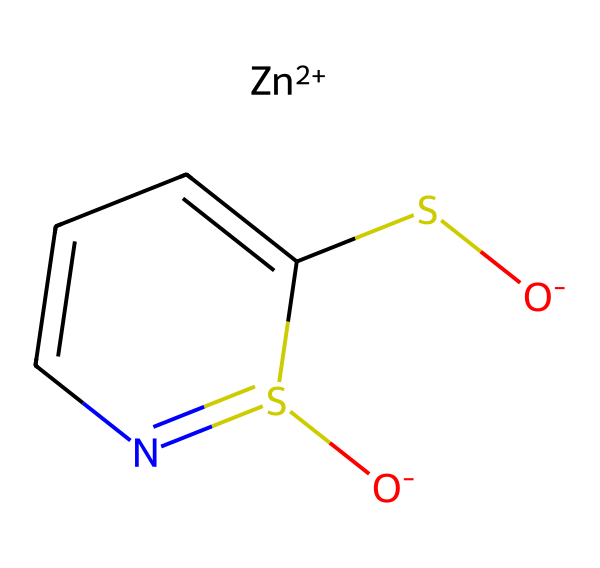What is the central metal atom in this compound? The SMILES notation indicates the presence of "[Zn+2]", which specifies zinc is the central metal atom due to its +2 oxidation state.
Answer: zinc How many sulfur atoms are in this compound? The structure shows two occurrences of the letter "S" in the SMILES, indicating that there are two sulfur atoms present in the compound.
Answer: 2 What functional groups are present in this chemical? Examining the SMILES, we see "S[O-]" indicating a sulfonate group, and "S1=NC=CC=C1" suggests a pyridine-like structure, which points to heterocyclic amine functionalities.
Answer: sulfonate and heterocyclic amine What is the oxidation state of zinc in this compound? The notation "[Zn+2]" clearly indicates that zinc is in a +2 oxidation state, which is necessary for its coordination with the ligand.
Answer: +2 Is this compound primarily ionic or covalent? The presence of a metal complexed with an anionic ligand (the sulfide and sulfonate) suggests that the compound exhibits ionic character, typical of organometallic compounds.
Answer: ionic What role does zinc pyrithione play in anti-dandruff shampoos? Zinc pyrithione is known to have antifungal properties, which makes it effective in combating dandruff caused by yeast-like fungi on the scalp.
Answer: antifungal How does the structure of zinc pyrithione contribute to its solubility in hair care products? The polar functional groups such as the sulfonate enhance the solubility in aqueous solutions, facilitating incorporation into shampoo formulations.
Answer: enhances solubility 